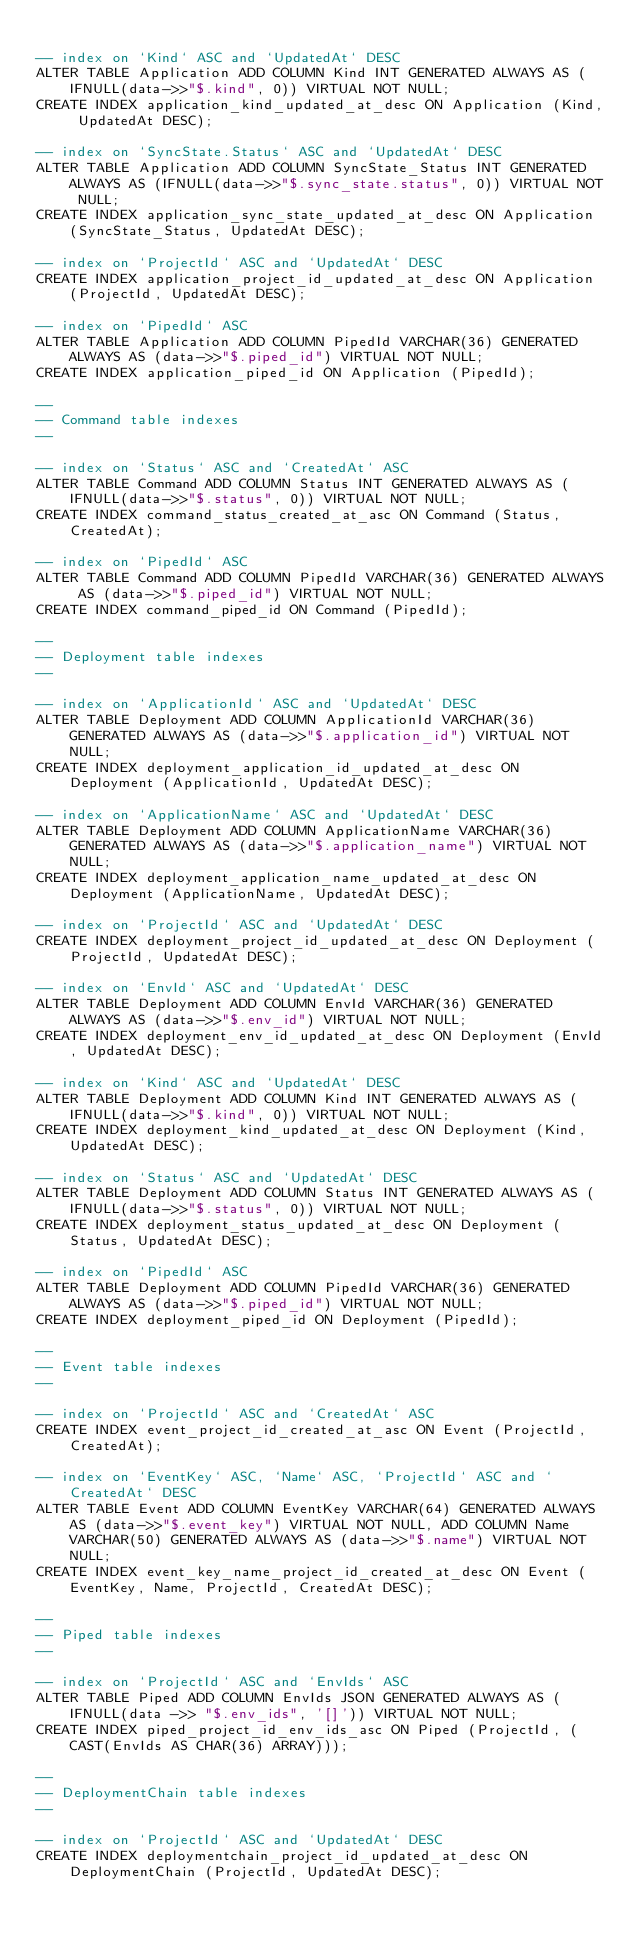Convert code to text. <code><loc_0><loc_0><loc_500><loc_500><_SQL_>
-- index on `Kind` ASC and `UpdatedAt` DESC
ALTER TABLE Application ADD COLUMN Kind INT GENERATED ALWAYS AS (IFNULL(data->>"$.kind", 0)) VIRTUAL NOT NULL;
CREATE INDEX application_kind_updated_at_desc ON Application (Kind, UpdatedAt DESC);

-- index on `SyncState.Status` ASC and `UpdatedAt` DESC
ALTER TABLE Application ADD COLUMN SyncState_Status INT GENERATED ALWAYS AS (IFNULL(data->>"$.sync_state.status", 0)) VIRTUAL NOT NULL;
CREATE INDEX application_sync_state_updated_at_desc ON Application (SyncState_Status, UpdatedAt DESC);

-- index on `ProjectId` ASC and `UpdatedAt` DESC
CREATE INDEX application_project_id_updated_at_desc ON Application (ProjectId, UpdatedAt DESC);

-- index on `PipedId` ASC
ALTER TABLE Application ADD COLUMN PipedId VARCHAR(36) GENERATED ALWAYS AS (data->>"$.piped_id") VIRTUAL NOT NULL;
CREATE INDEX application_piped_id ON Application (PipedId);

--
-- Command table indexes
--

-- index on `Status` ASC and `CreatedAt` ASC
ALTER TABLE Command ADD COLUMN Status INT GENERATED ALWAYS AS (IFNULL(data->>"$.status", 0)) VIRTUAL NOT NULL;
CREATE INDEX command_status_created_at_asc ON Command (Status, CreatedAt);

-- index on `PipedId` ASC
ALTER TABLE Command ADD COLUMN PipedId VARCHAR(36) GENERATED ALWAYS AS (data->>"$.piped_id") VIRTUAL NOT NULL;
CREATE INDEX command_piped_id ON Command (PipedId);

--
-- Deployment table indexes
--

-- index on `ApplicationId` ASC and `UpdatedAt` DESC
ALTER TABLE Deployment ADD COLUMN ApplicationId VARCHAR(36) GENERATED ALWAYS AS (data->>"$.application_id") VIRTUAL NOT NULL;
CREATE INDEX deployment_application_id_updated_at_desc ON Deployment (ApplicationId, UpdatedAt DESC);

-- index on `ApplicationName` ASC and `UpdatedAt` DESC
ALTER TABLE Deployment ADD COLUMN ApplicationName VARCHAR(36) GENERATED ALWAYS AS (data->>"$.application_name") VIRTUAL NOT NULL;
CREATE INDEX deployment_application_name_updated_at_desc ON Deployment (ApplicationName, UpdatedAt DESC);

-- index on `ProjectId` ASC and `UpdatedAt` DESC
CREATE INDEX deployment_project_id_updated_at_desc ON Deployment (ProjectId, UpdatedAt DESC);

-- index on `EnvId` ASC and `UpdatedAt` DESC
ALTER TABLE Deployment ADD COLUMN EnvId VARCHAR(36) GENERATED ALWAYS AS (data->>"$.env_id") VIRTUAL NOT NULL;
CREATE INDEX deployment_env_id_updated_at_desc ON Deployment (EnvId, UpdatedAt DESC);

-- index on `Kind` ASC and `UpdatedAt` DESC
ALTER TABLE Deployment ADD COLUMN Kind INT GENERATED ALWAYS AS (IFNULL(data->>"$.kind", 0)) VIRTUAL NOT NULL;
CREATE INDEX deployment_kind_updated_at_desc ON Deployment (Kind, UpdatedAt DESC);

-- index on `Status` ASC and `UpdatedAt` DESC
ALTER TABLE Deployment ADD COLUMN Status INT GENERATED ALWAYS AS (IFNULL(data->>"$.status", 0)) VIRTUAL NOT NULL;
CREATE INDEX deployment_status_updated_at_desc ON Deployment (Status, UpdatedAt DESC);

-- index on `PipedId` ASC
ALTER TABLE Deployment ADD COLUMN PipedId VARCHAR(36) GENERATED ALWAYS AS (data->>"$.piped_id") VIRTUAL NOT NULL;
CREATE INDEX deployment_piped_id ON Deployment (PipedId);

--
-- Event table indexes
--

-- index on `ProjectId` ASC and `CreatedAt` ASC
CREATE INDEX event_project_id_created_at_asc ON Event (ProjectId, CreatedAt);

-- index on `EventKey` ASC, `Name` ASC, `ProjectId` ASC and `CreatedAt` DESC
ALTER TABLE Event ADD COLUMN EventKey VARCHAR(64) GENERATED ALWAYS AS (data->>"$.event_key") VIRTUAL NOT NULL, ADD COLUMN Name VARCHAR(50) GENERATED ALWAYS AS (data->>"$.name") VIRTUAL NOT NULL;
CREATE INDEX event_key_name_project_id_created_at_desc ON Event (EventKey, Name, ProjectId, CreatedAt DESC);

--
-- Piped table indexes
--

-- index on `ProjectId` ASC and `EnvIds` ASC
ALTER TABLE Piped ADD COLUMN EnvIds JSON GENERATED ALWAYS AS (IFNULL(data ->> "$.env_ids", '[]')) VIRTUAL NOT NULL;
CREATE INDEX piped_project_id_env_ids_asc ON Piped (ProjectId, (CAST(EnvIds AS CHAR(36) ARRAY)));

--
-- DeploymentChain table indexes
--

-- index on `ProjectId` ASC and `UpdatedAt` DESC
CREATE INDEX deploymentchain_project_id_updated_at_desc ON DeploymentChain (ProjectId, UpdatedAt DESC);
</code> 